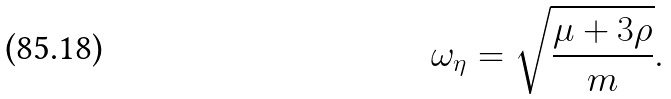Convert formula to latex. <formula><loc_0><loc_0><loc_500><loc_500>\omega _ { \eta } = \sqrt { \frac { \mu + 3 \rho } { m } } .</formula> 